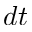Convert formula to latex. <formula><loc_0><loc_0><loc_500><loc_500>d t</formula> 